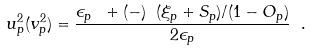<formula> <loc_0><loc_0><loc_500><loc_500>u _ { p } ^ { 2 } ( v _ { p } ^ { 2 } ) = \frac { \epsilon _ { p } \ + ( - ) \ ( \xi _ { p } + S _ { p } ) / ( 1 - O _ { p } ) } { 2 \epsilon _ { p } } \ .</formula> 